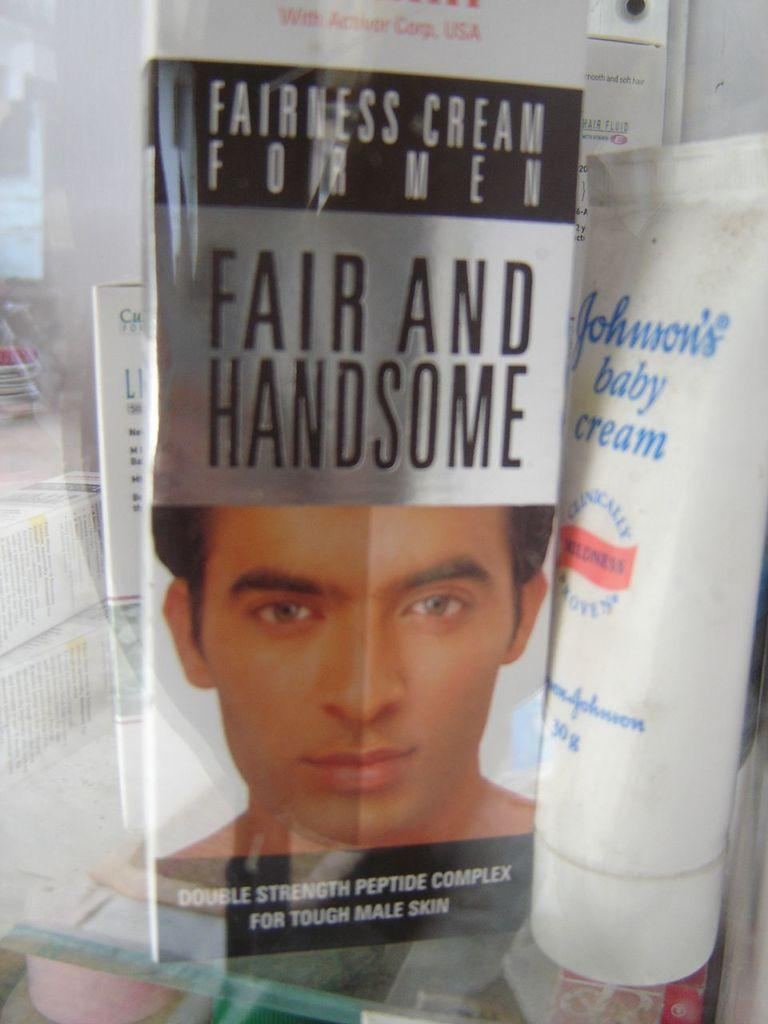What types of creams are visible in the image? There is a baby cream and a fairness cream in the image. Can you describe the purpose of each cream? The baby cream is likely for use on a baby's skin, while the fairness cream may be for skin lightening or evening. What level of ink is present in the pen shown in the image? There is no pen present in the image; it only features two types of creams. 